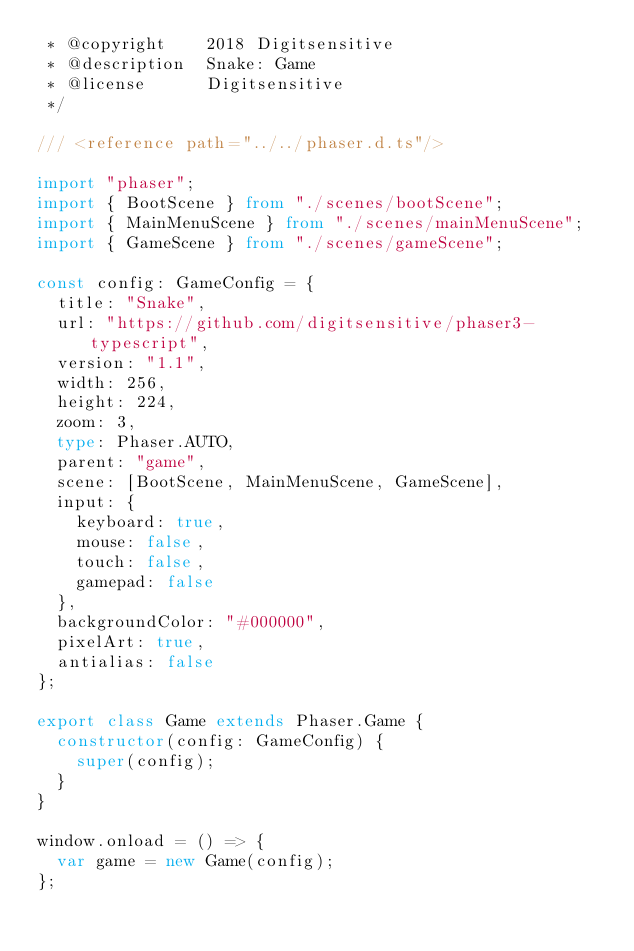Convert code to text. <code><loc_0><loc_0><loc_500><loc_500><_TypeScript_> * @copyright    2018 Digitsensitive
 * @description  Snake: Game
 * @license      Digitsensitive
 */

/// <reference path="../../phaser.d.ts"/>

import "phaser";
import { BootScene } from "./scenes/bootScene";
import { MainMenuScene } from "./scenes/mainMenuScene";
import { GameScene } from "./scenes/gameScene";

const config: GameConfig = {
  title: "Snake",
  url: "https://github.com/digitsensitive/phaser3-typescript",
  version: "1.1",
  width: 256,
  height: 224,
  zoom: 3,
  type: Phaser.AUTO,
  parent: "game",
  scene: [BootScene, MainMenuScene, GameScene],
  input: {
    keyboard: true,
    mouse: false,
    touch: false,
    gamepad: false
  },
  backgroundColor: "#000000",
  pixelArt: true,
  antialias: false
};

export class Game extends Phaser.Game {
  constructor(config: GameConfig) {
    super(config);
  }
}

window.onload = () => {
  var game = new Game(config);
};
</code> 